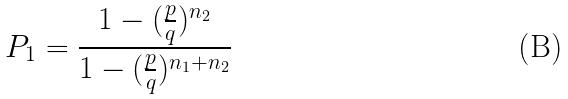<formula> <loc_0><loc_0><loc_500><loc_500>P _ { 1 } = \frac { 1 - ( \frac { p } { q } ) ^ { n _ { 2 } } } { 1 - ( \frac { p } { q } ) ^ { n _ { 1 } + n _ { 2 } } }</formula> 